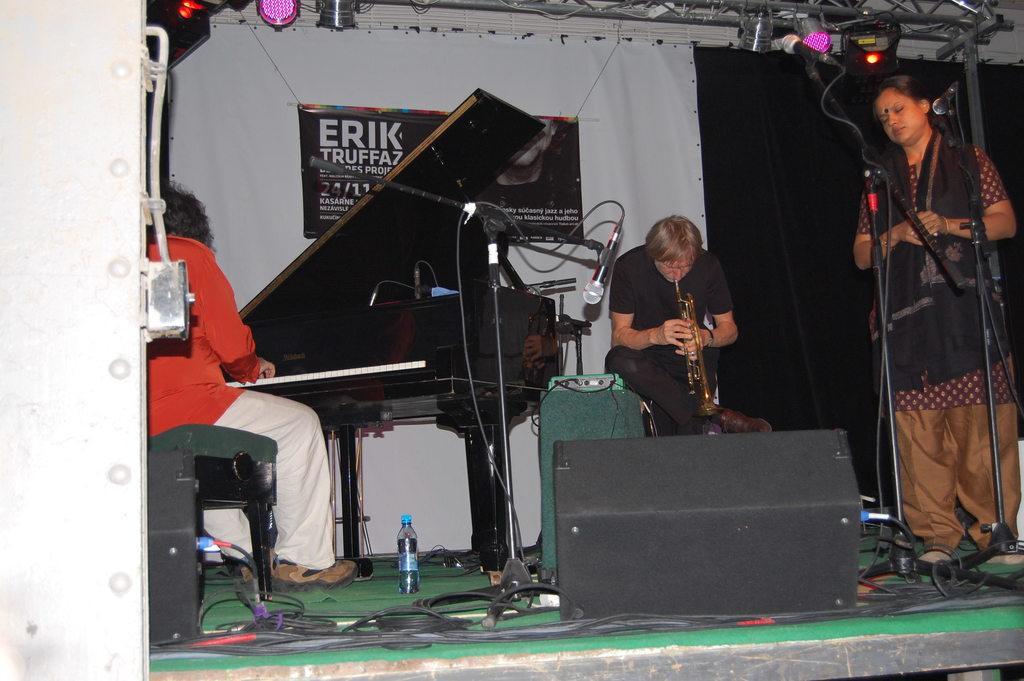In one or two sentences, can you explain what this image depicts? In the image there were three people in the left he is playing key board. And in the center he is playing saxophone,and the right corner one lady she is listening the music. Here there is microphone and some musical instruments and water bottle. 